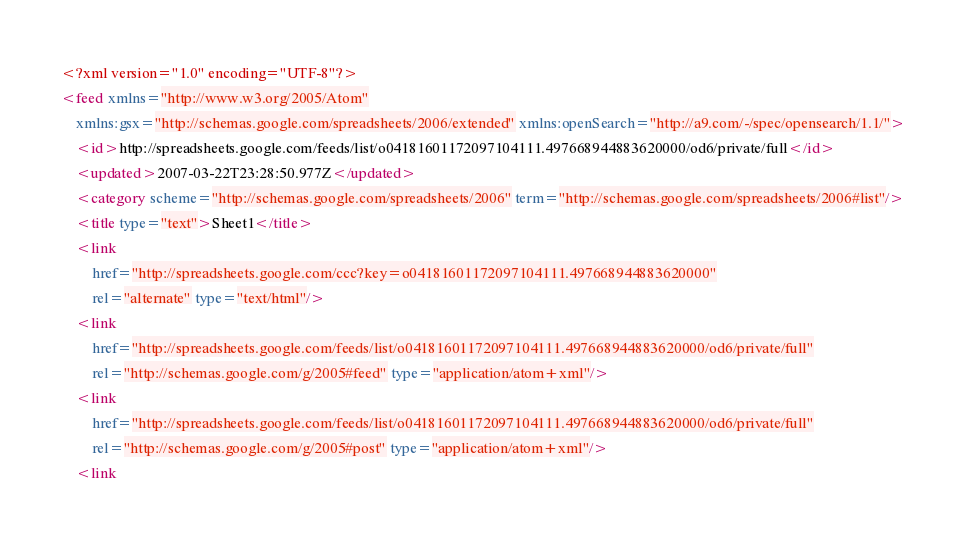Convert code to text. <code><loc_0><loc_0><loc_500><loc_500><_XML_><?xml version="1.0" encoding="UTF-8"?>
<feed xmlns="http://www.w3.org/2005/Atom"
    xmlns:gsx="http://schemas.google.com/spreadsheets/2006/extended" xmlns:openSearch="http://a9.com/-/spec/opensearch/1.1/">
    <id>http://spreadsheets.google.com/feeds/list/o04181601172097104111.497668944883620000/od6/private/full</id>
    <updated>2007-03-22T23:28:50.977Z</updated>
    <category scheme="http://schemas.google.com/spreadsheets/2006" term="http://schemas.google.com/spreadsheets/2006#list"/>
    <title type="text">Sheet1</title>
    <link
        href="http://spreadsheets.google.com/ccc?key=o04181601172097104111.497668944883620000"
        rel="alternate" type="text/html"/>
    <link
        href="http://spreadsheets.google.com/feeds/list/o04181601172097104111.497668944883620000/od6/private/full"
        rel="http://schemas.google.com/g/2005#feed" type="application/atom+xml"/>
    <link
        href="http://spreadsheets.google.com/feeds/list/o04181601172097104111.497668944883620000/od6/private/full"
        rel="http://schemas.google.com/g/2005#post" type="application/atom+xml"/>
    <link</code> 